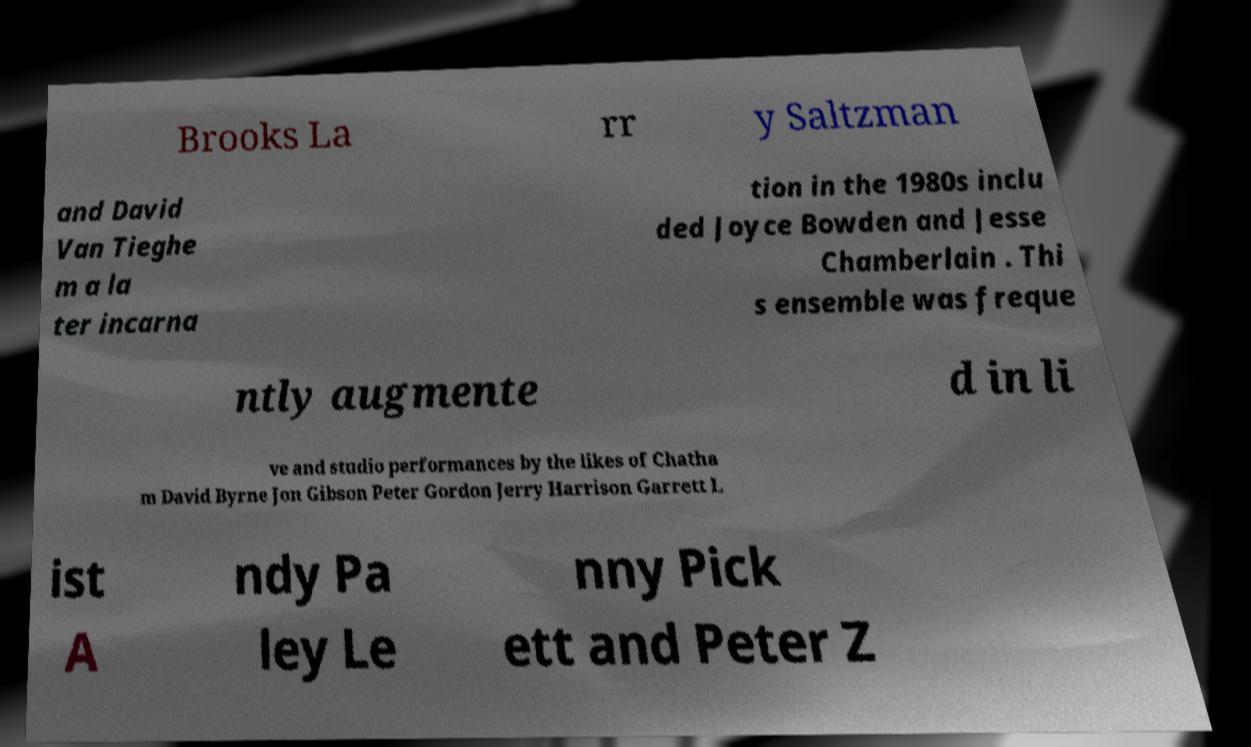Can you read and provide the text displayed in the image?This photo seems to have some interesting text. Can you extract and type it out for me? Brooks La rr y Saltzman and David Van Tieghe m a la ter incarna tion in the 1980s inclu ded Joyce Bowden and Jesse Chamberlain . Thi s ensemble was freque ntly augmente d in li ve and studio performances by the likes of Chatha m David Byrne Jon Gibson Peter Gordon Jerry Harrison Garrett L ist A ndy Pa ley Le nny Pick ett and Peter Z 